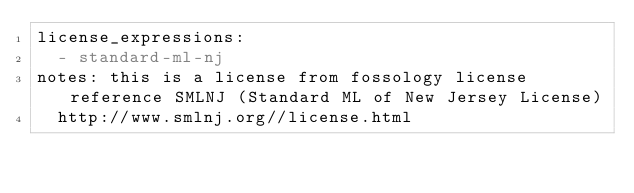<code> <loc_0><loc_0><loc_500><loc_500><_YAML_>license_expressions:
  - standard-ml-nj
notes: this is a license from fossology license reference SMLNJ (Standard ML of New Jersey License)
  http://www.smlnj.org//license.html
</code> 